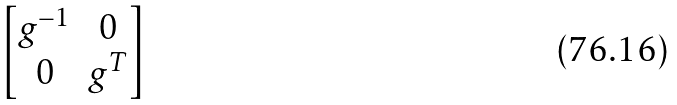<formula> <loc_0><loc_0><loc_500><loc_500>\begin{bmatrix} g ^ { - 1 } & 0 \\ 0 & g ^ { T } \end{bmatrix}</formula> 